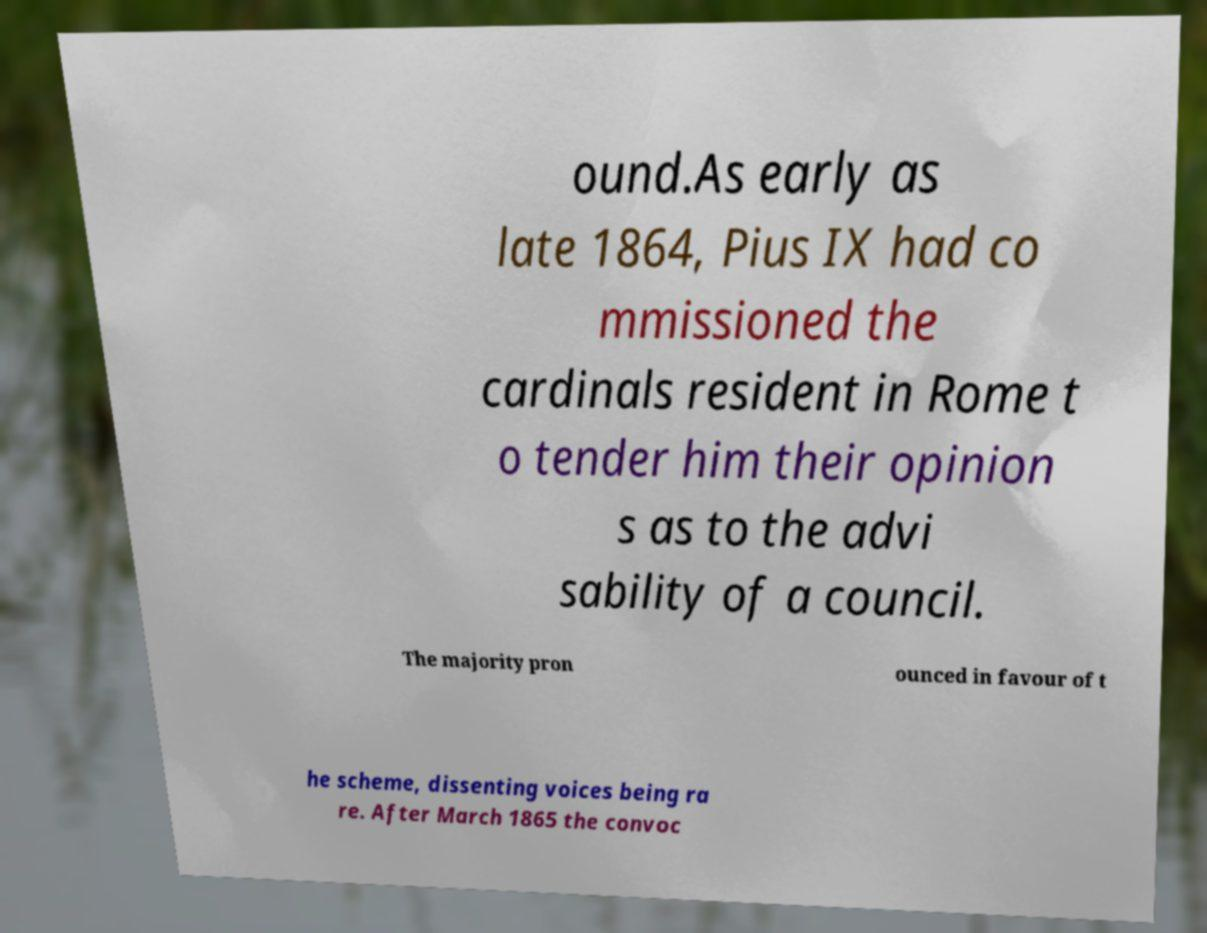Could you assist in decoding the text presented in this image and type it out clearly? ound.As early as late 1864, Pius IX had co mmissioned the cardinals resident in Rome t o tender him their opinion s as to the advi sability of a council. The majority pron ounced in favour of t he scheme, dissenting voices being ra re. After March 1865 the convoc 